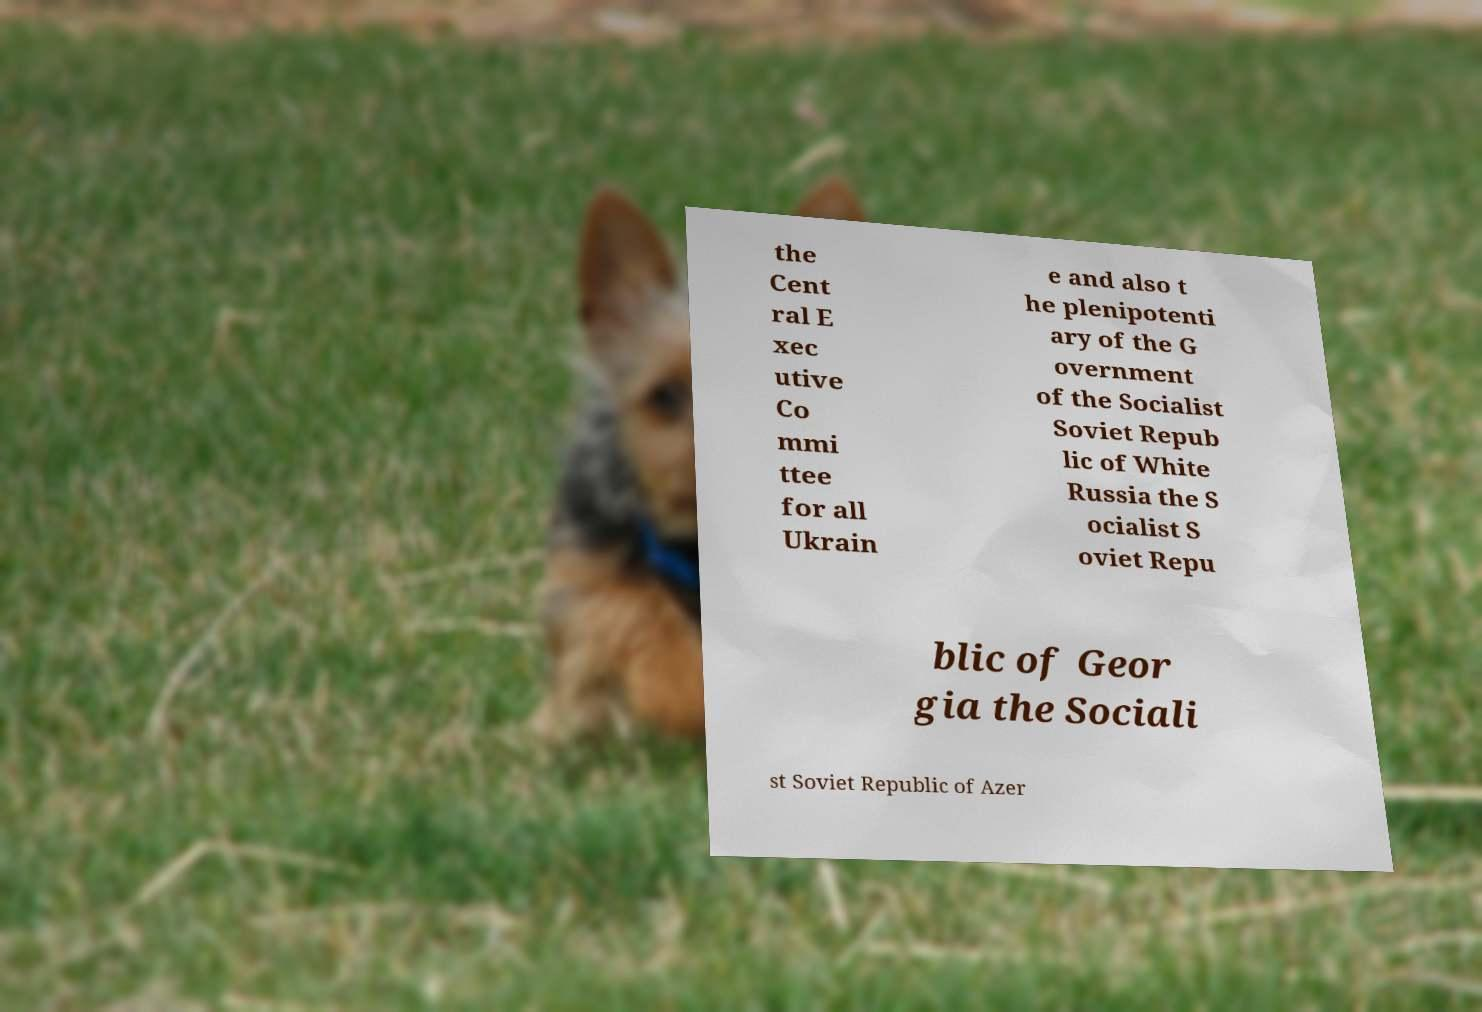I need the written content from this picture converted into text. Can you do that? the Cent ral E xec utive Co mmi ttee for all Ukrain e and also t he plenipotenti ary of the G overnment of the Socialist Soviet Repub lic of White Russia the S ocialist S oviet Repu blic of Geor gia the Sociali st Soviet Republic of Azer 